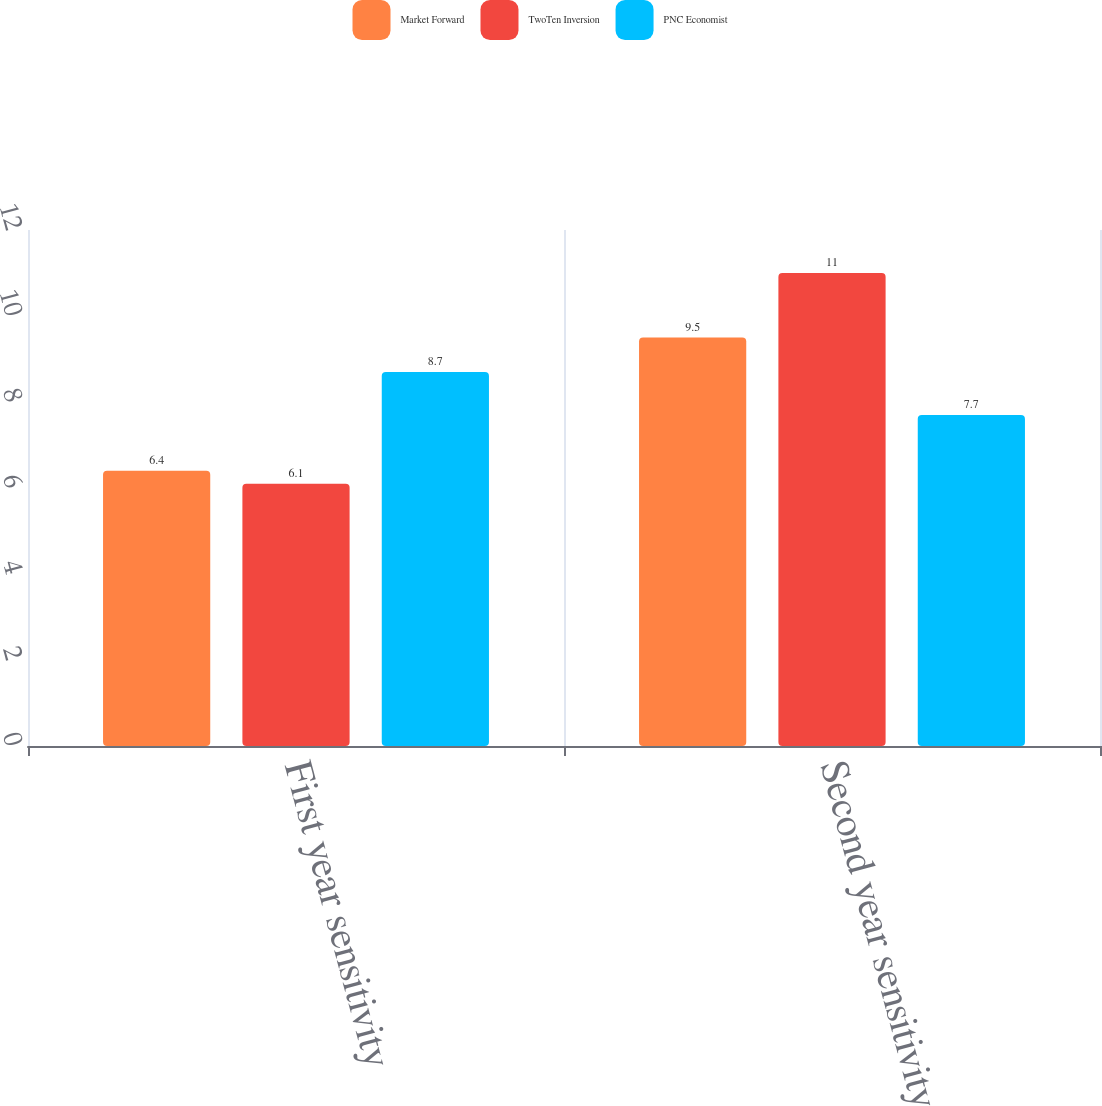<chart> <loc_0><loc_0><loc_500><loc_500><stacked_bar_chart><ecel><fcel>First year sensitivity<fcel>Second year sensitivity<nl><fcel>Market Forward<fcel>6.4<fcel>9.5<nl><fcel>TwoTen Inversion<fcel>6.1<fcel>11<nl><fcel>PNC Economist<fcel>8.7<fcel>7.7<nl></chart> 